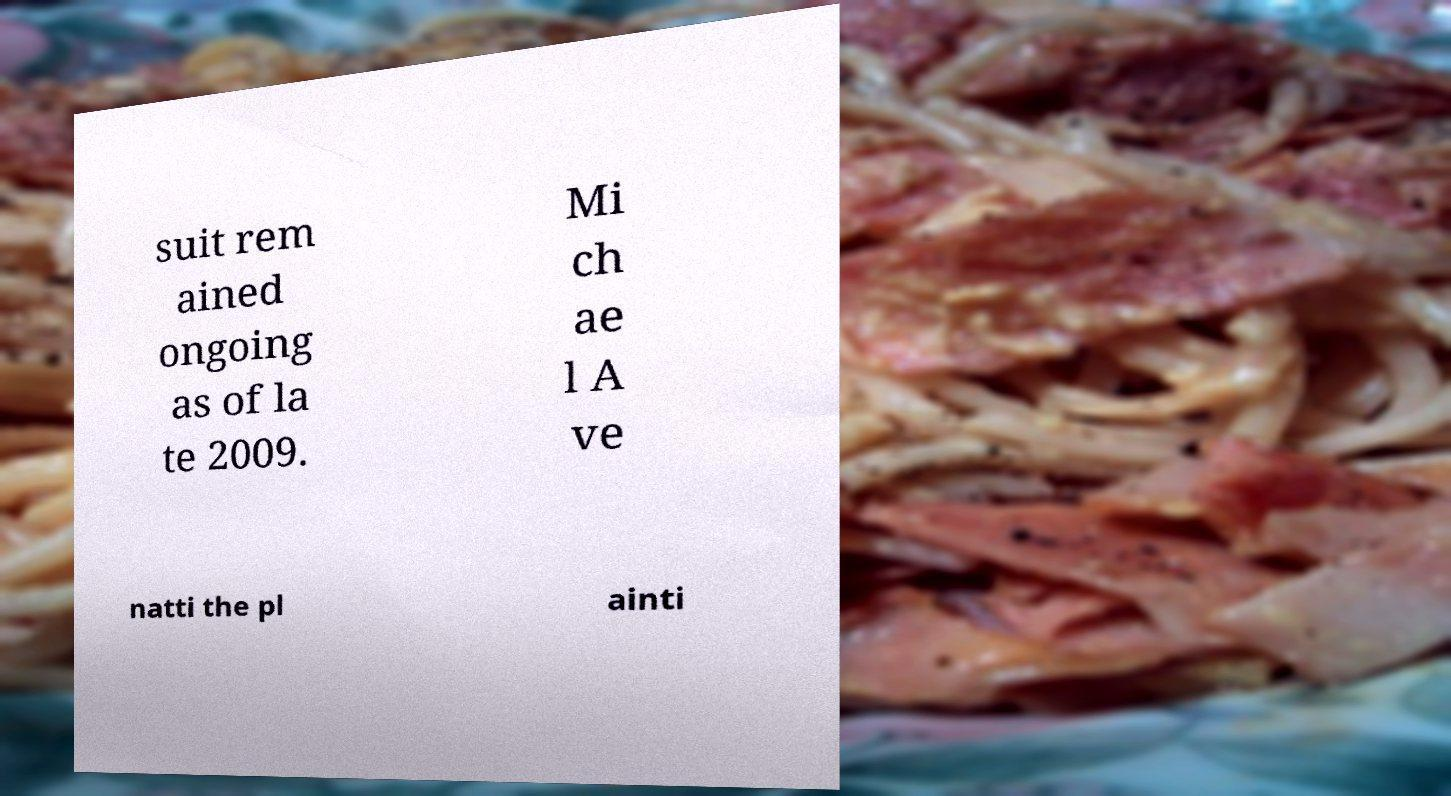Could you assist in decoding the text presented in this image and type it out clearly? suit rem ained ongoing as of la te 2009. Mi ch ae l A ve natti the pl ainti 